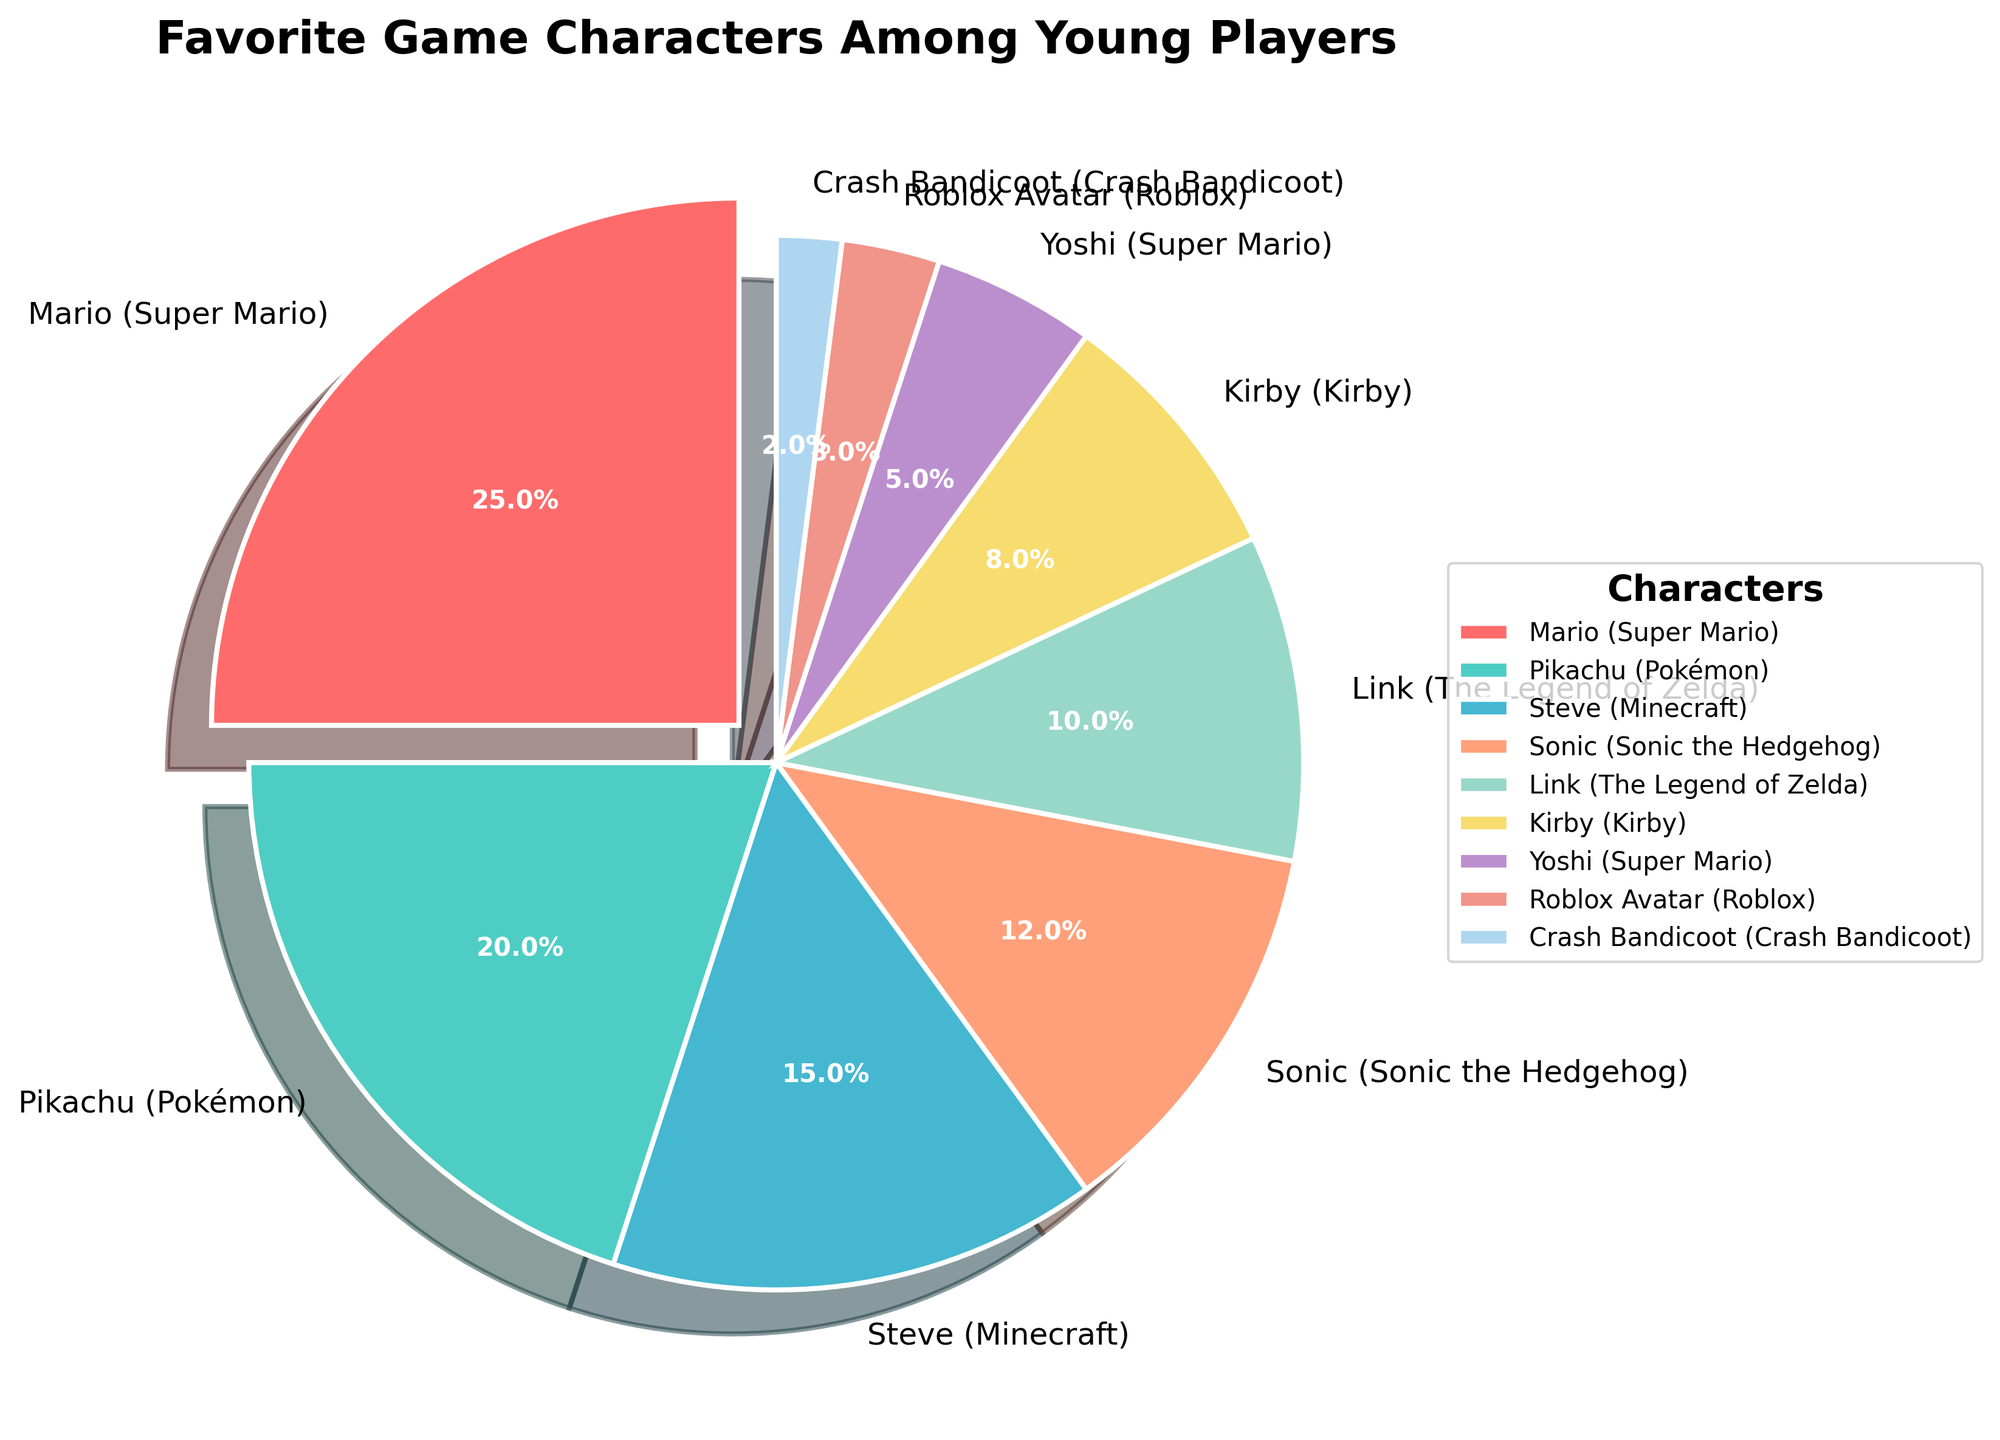What percentage of young players chose the character from the "Super Mario" franchise? Look for the segment labeled "Mario (Super Mario)" in the pie chart. Its percentage is provided next to the label.
Answer: 25% Which character is chosen by the smallest percentage of young players? Identify the segment with the smallest percentage. This segment will also have the smallest wedge size in the pie chart.
Answer: Crash Bandicoot (2%) Is the percentage of players who chose Pikachu (Pokémon) greater than the percentage who chose Link (The Legend of Zelda)? Compare the two percentages directly from the labels in the pie chart: Pikachu (20%) and Link (10%).
Answer: Yes Add the percentages of players who chose Steve (Minecraft) and Sonic (Sonic the Hedgehog). What is the sum? Look for the segments labeled "Steve (Minecraft)" and "Sonic (Sonic the Hedgehog)". Add their percentages: 15% + 12%.
Answer: 27% Which segment has a shadow effect and is slightly exploded outwards? Identify the segment which is visually different (exploded) and has a shadow. This segment represents the highest percentage.
Answer: Mario (Super Mario) How many characters have a percentage less than 10%? Count all the segments with percentages less than 10% by checking each label.
Answer: 4 Is the percentage of players preferring Yoshi greater than or equal to the percentage preferring Kirby? Compare the percentages next to the labels "Yoshi (Super Mario)" which is 5% and "Kirby (Kirby)" which is 8%.
Answer: No What is the combined percentage of players who chose characters from the Super Mario franchise (Mario and Yoshi)? Find the segments with the labels "Mario (Super Mario)" and "Yoshi (Super Mario)" and add their percentages: 25% + 5%.
Answer: 30% Which color represents Pikachu (Pokémon) in the pie chart? Identify the color associated with the segment labeled "Pikachu (Pokémon)". The colors are visually distinct and easy to identify.
Answer: Green 